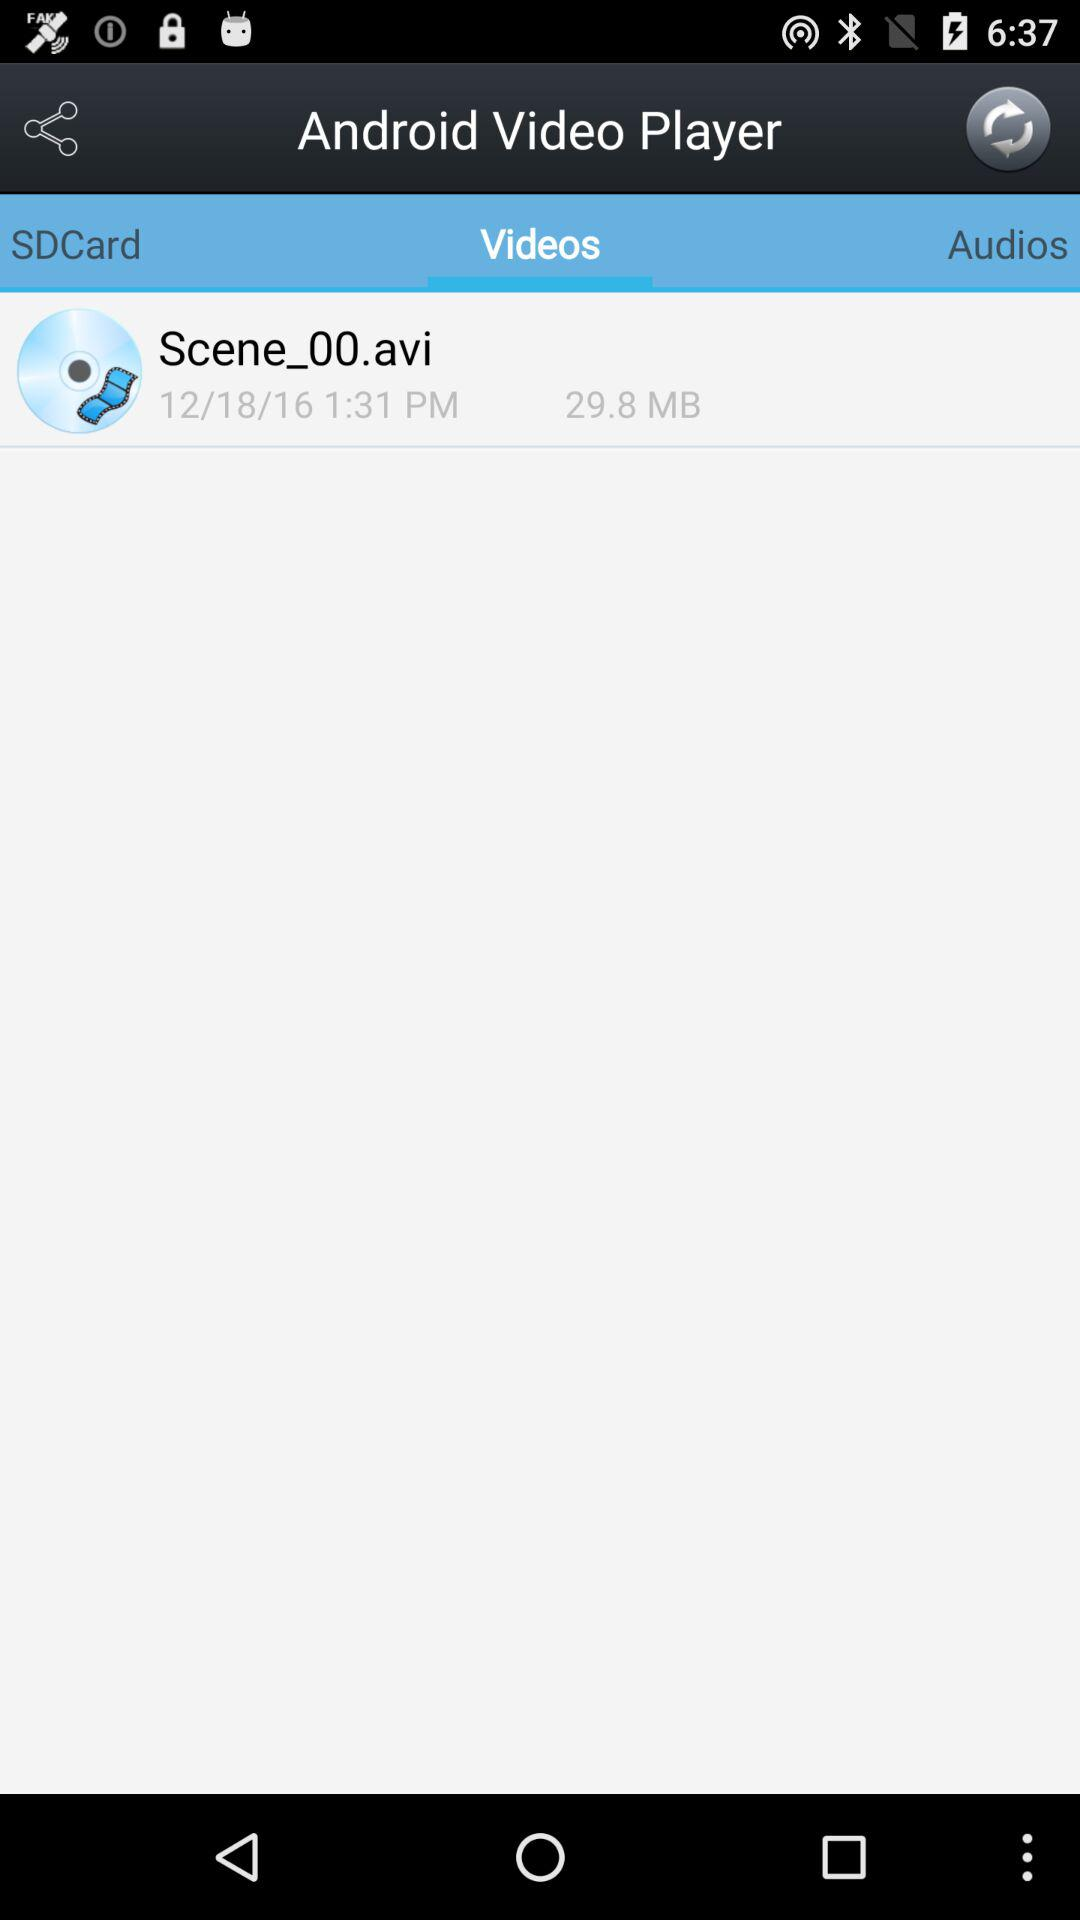What is the size of the video? The size is 29.8 MB. 